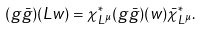Convert formula to latex. <formula><loc_0><loc_0><loc_500><loc_500>( g \bar { g } ) ( L w ) = \chi _ { L ^ { \mu } } ^ { * } ( g \bar { g } ) ( w ) \bar { \chi } _ { L ^ { \mu } } ^ { * } .</formula> 